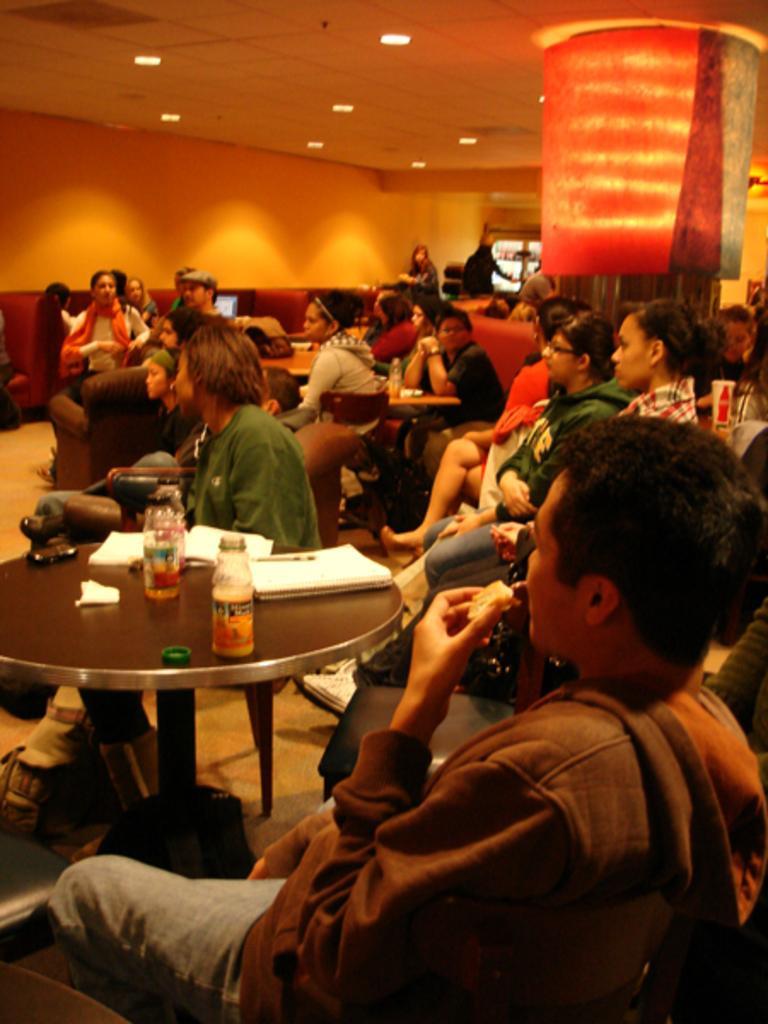Please provide a concise description of this image. This is a picture taken in a room, there are a group of people sitting on chairs in front of these people there is a table on the table there are bottle, book, pen and a bag. Behind the people there is a pillar and a wall and there is a ceiling light on top. 